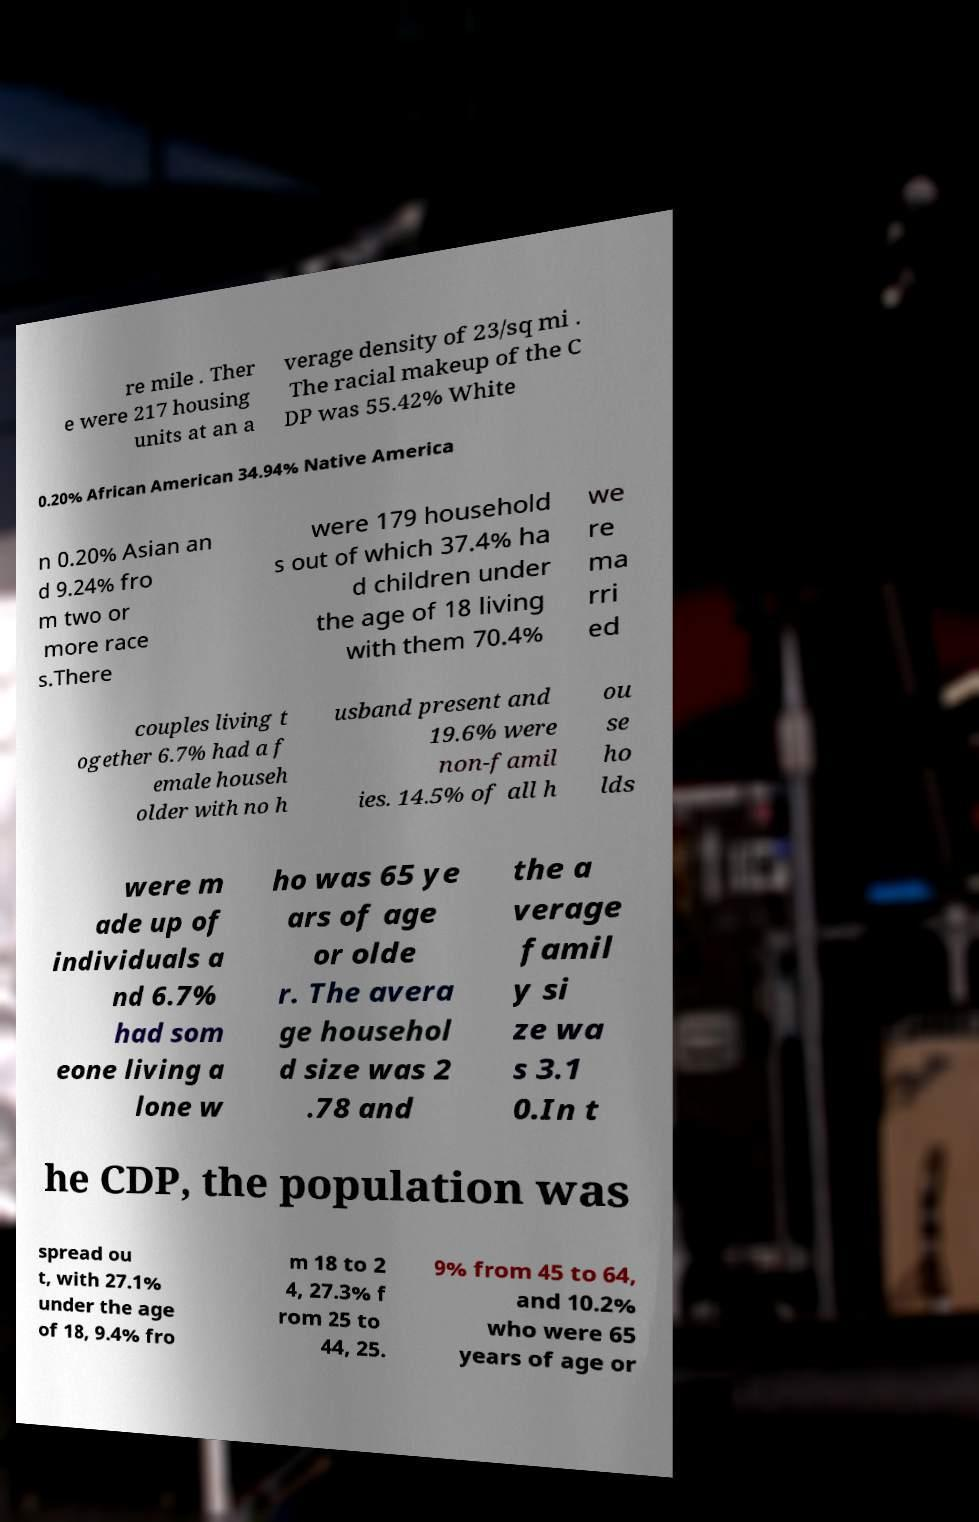There's text embedded in this image that I need extracted. Can you transcribe it verbatim? re mile . Ther e were 217 housing units at an a verage density of 23/sq mi . The racial makeup of the C DP was 55.42% White 0.20% African American 34.94% Native America n 0.20% Asian an d 9.24% fro m two or more race s.There were 179 household s out of which 37.4% ha d children under the age of 18 living with them 70.4% we re ma rri ed couples living t ogether 6.7% had a f emale househ older with no h usband present and 19.6% were non-famil ies. 14.5% of all h ou se ho lds were m ade up of individuals a nd 6.7% had som eone living a lone w ho was 65 ye ars of age or olde r. The avera ge househol d size was 2 .78 and the a verage famil y si ze wa s 3.1 0.In t he CDP, the population was spread ou t, with 27.1% under the age of 18, 9.4% fro m 18 to 2 4, 27.3% f rom 25 to 44, 25. 9% from 45 to 64, and 10.2% who were 65 years of age or 